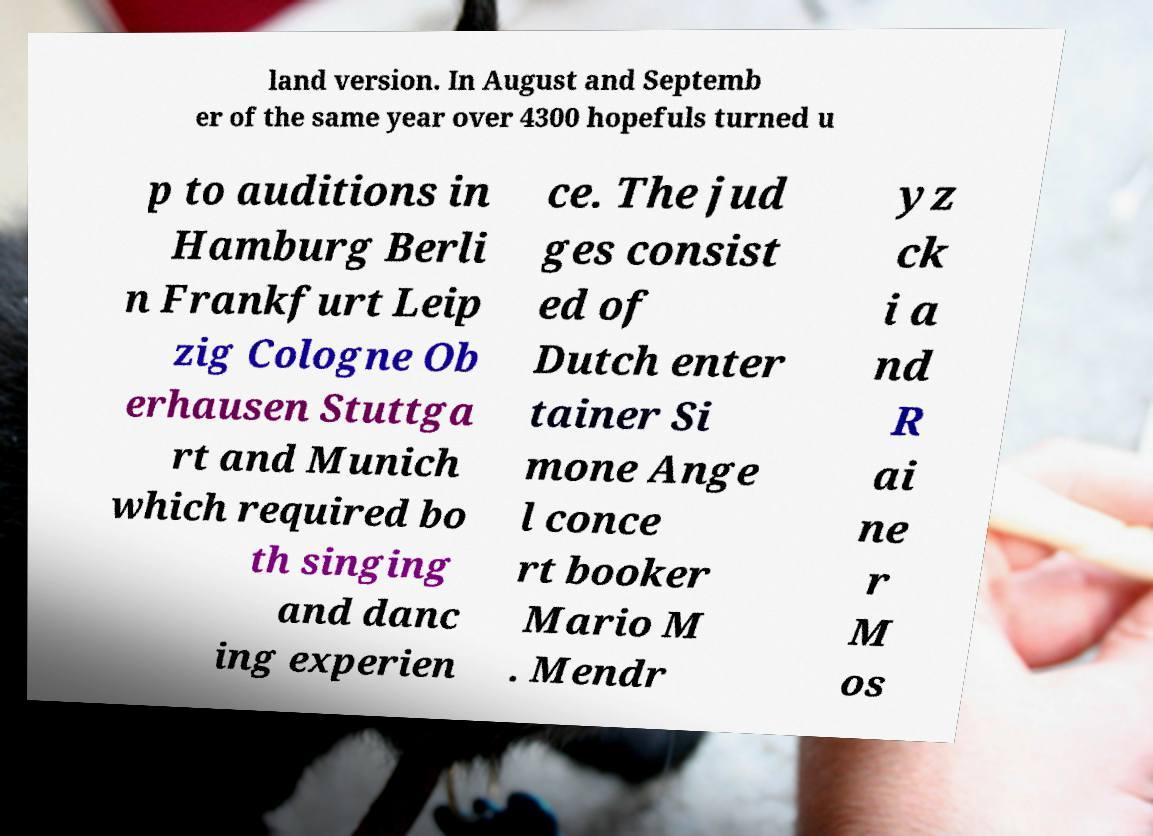For documentation purposes, I need the text within this image transcribed. Could you provide that? land version. In August and Septemb er of the same year over 4300 hopefuls turned u p to auditions in Hamburg Berli n Frankfurt Leip zig Cologne Ob erhausen Stuttga rt and Munich which required bo th singing and danc ing experien ce. The jud ges consist ed of Dutch enter tainer Si mone Ange l conce rt booker Mario M . Mendr yz ck i a nd R ai ne r M os 